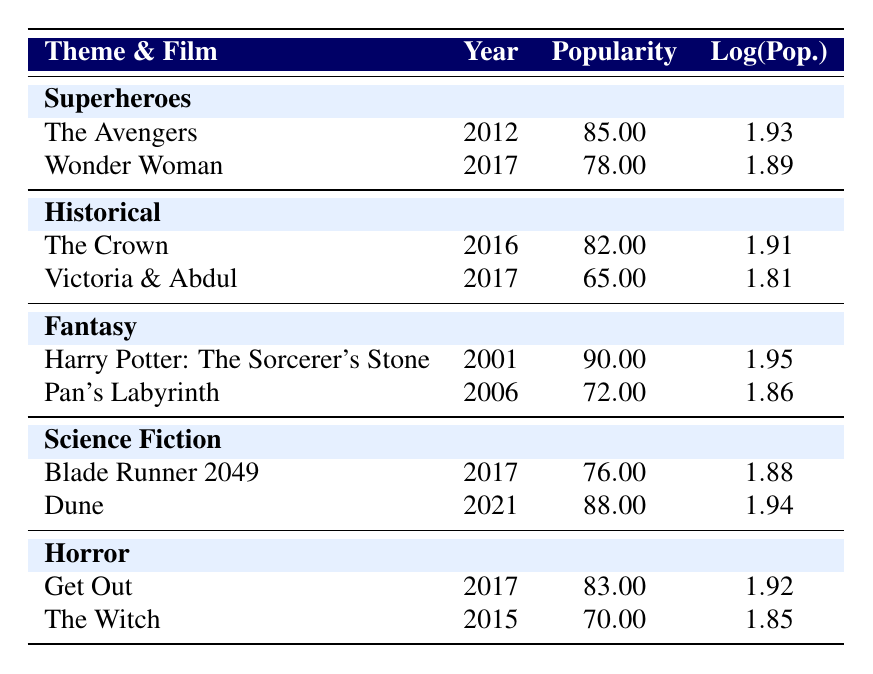What is the popularity score of "The Avengers"? The table lists a popularity score for "The Avengers" in the row under the Superheroes theme, which is 85.00.
Answer: 85.00 Which film has the highest popularity score in the Historical theme? Under the Historical theme, "The Crown" has a popularity score of 82.00, while "Victoria & Abdul" has a score of 65.00, making "The Crown" the highest.
Answer: The Crown What is the average popularity score for films in the Fantasy theme? The scores for films in the Fantasy theme are 90.00 and 72.00. Summing these gives 162.00, and dividing by the number of films (2) gives an average of 81.00.
Answer: 81.00 Is the popularity score of "Get Out" greater than that of "Dune"? "Get Out" has a popularity score of 83.00, while "Dune" has a score of 88.00. Since 83.00 is less than 88.00, the statement is false.
Answer: No Which costume theme has the lowest average popularity score based on the films listed? To find the average, calculate for each theme: Superheroes average is 81.50, Historical is 73.50, Fantasy is 81.00, Science Fiction is 82.00, and Horror is 76.50. The lowest average is for the Historical theme.
Answer: Historical What is the difference in popularity between the highest and lowest scored films in the Science Fiction theme? In the Science Fiction theme, "Dune" has a score of 88.00 and "Blade Runner 2049" has a score of 76.00. The difference is 88.00 - 76.00 = 12.00.
Answer: 12.00 Did any films from the Horror theme have popularity scores below 75? The table lists "Get Out" with 83.00 and "The Witch" with 70.00, confirming that "The Witch" has a score below 75. Thus, the answer is yes.
Answer: Yes Which film in the Fantasy theme has the lowest popularity score? Looking at the Fantasy theme, "Pan's Labyrinth" has a popularity score of 72.00, which is lower than "Harry Potter: The Sorcerer's Stone" at 90.00, making it the lowest.
Answer: Pan's Labyrinth What is the log of the popularity score for "Wonder Woman"? The log of the popularity score for "Wonder Woman" is listed in the table as 1.89. This value corresponds directly to its popularity score of 78.00.
Answer: 1.89 